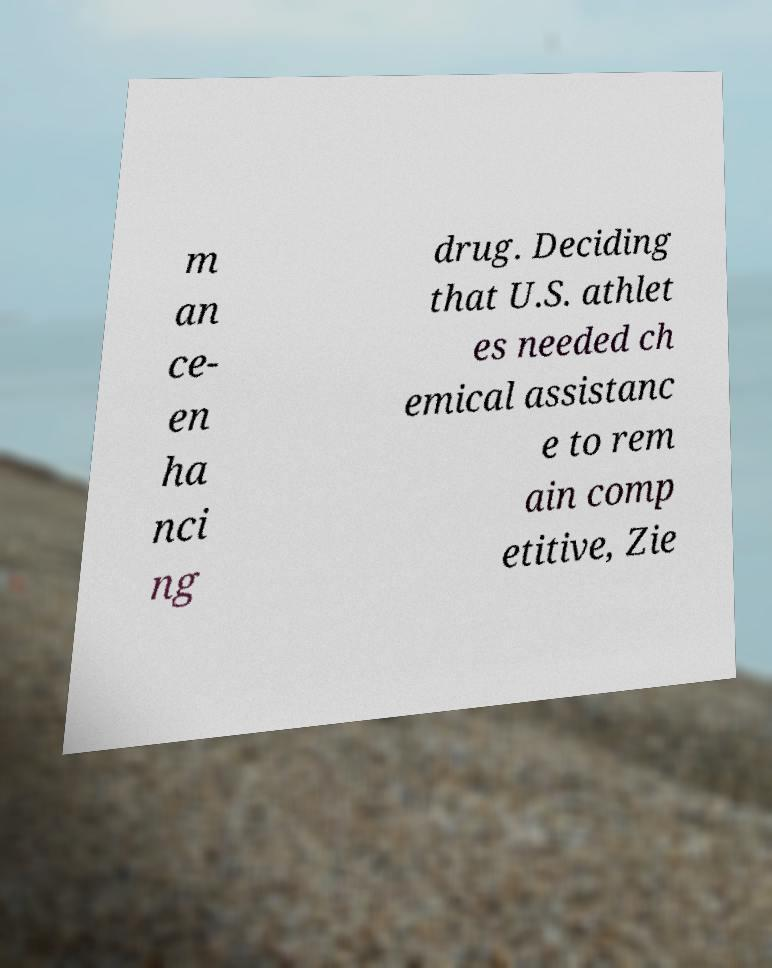Could you assist in decoding the text presented in this image and type it out clearly? m an ce- en ha nci ng drug. Deciding that U.S. athlet es needed ch emical assistanc e to rem ain comp etitive, Zie 